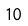Convert formula to latex. <formula><loc_0><loc_0><loc_500><loc_500>1 0</formula> 